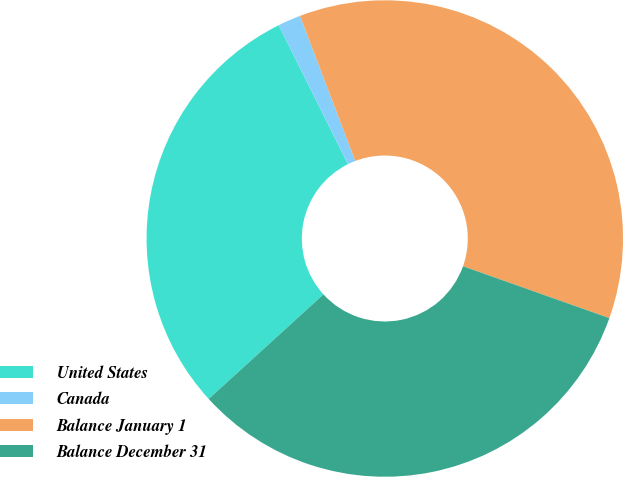Convert chart to OTSL. <chart><loc_0><loc_0><loc_500><loc_500><pie_chart><fcel>United States<fcel>Canada<fcel>Balance January 1<fcel>Balance December 31<nl><fcel>29.42%<fcel>1.55%<fcel>36.22%<fcel>32.82%<nl></chart> 